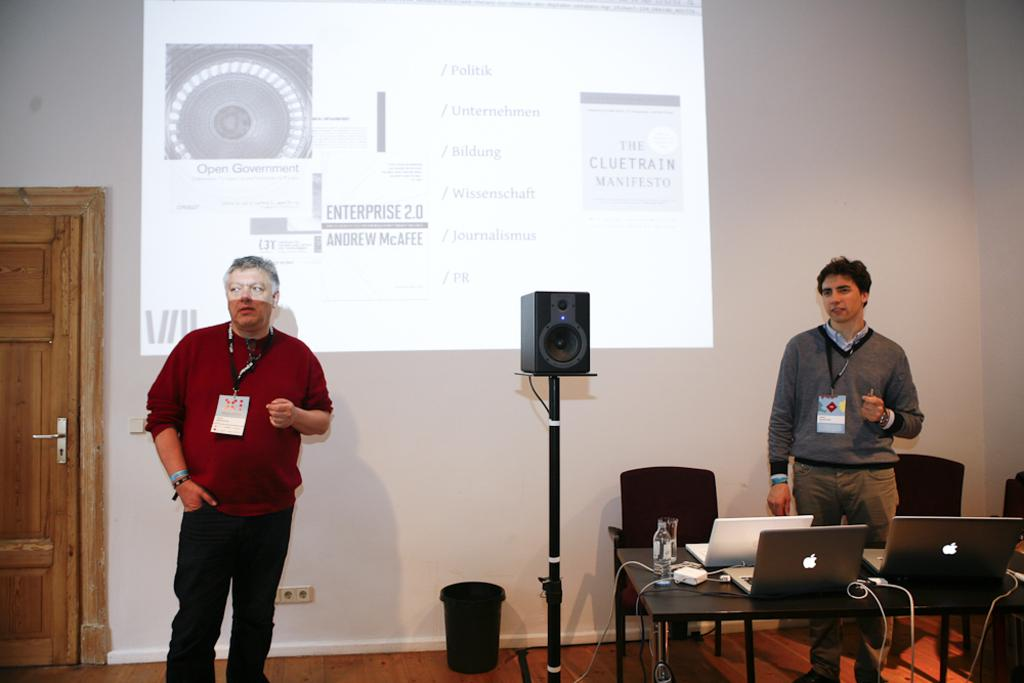How many people are present in the image? There are 2 people in the image. What objects can be seen on the table? There are laptops, a bottle, and a glass on the table. What is on the wall in the image? There is a screen on the wall. What type of audio equipment is present in the image? There is a speaker with a stand in the image. Where is the door located in the image? The door is on the left side of the image. What type of copper material is used to make the music in the image? There is no copper material or music present in the image. 